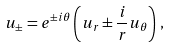<formula> <loc_0><loc_0><loc_500><loc_500>u _ { \pm } = e ^ { \pm i \theta } \left ( u _ { r } \pm \frac { i } { r } u _ { \theta } \right ) \, ,</formula> 